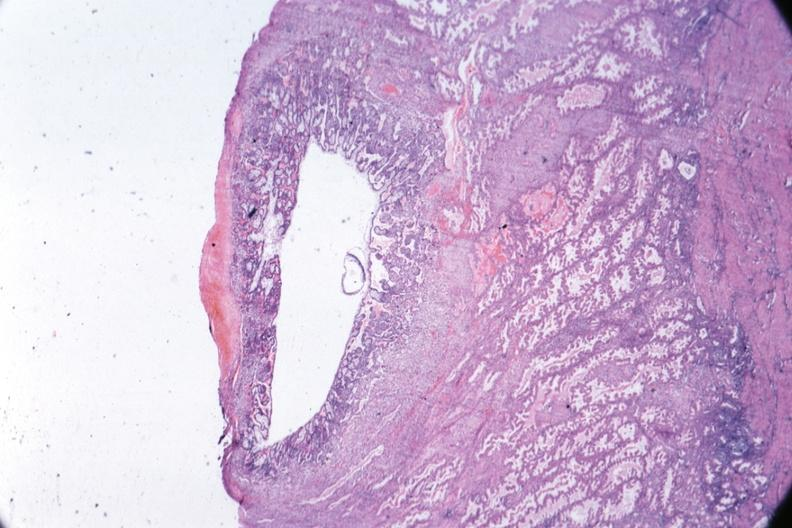what is present?
Answer the question using a single word or phrase. Fetus developing very early 